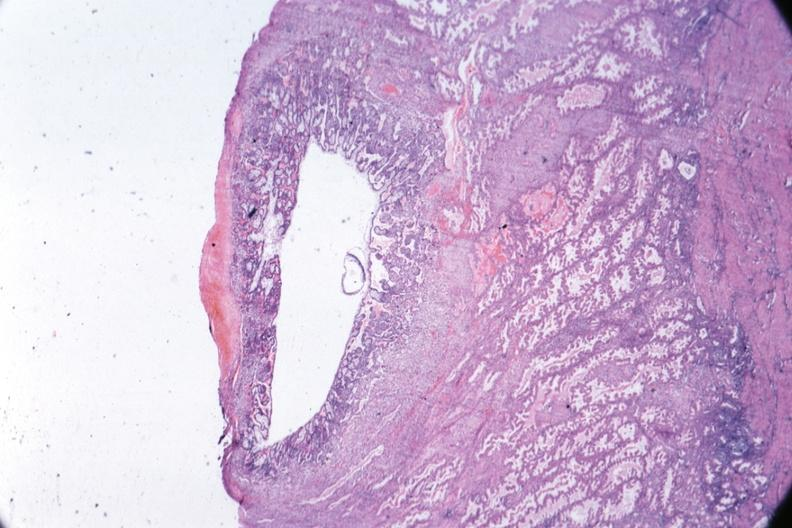what is present?
Answer the question using a single word or phrase. Fetus developing very early 